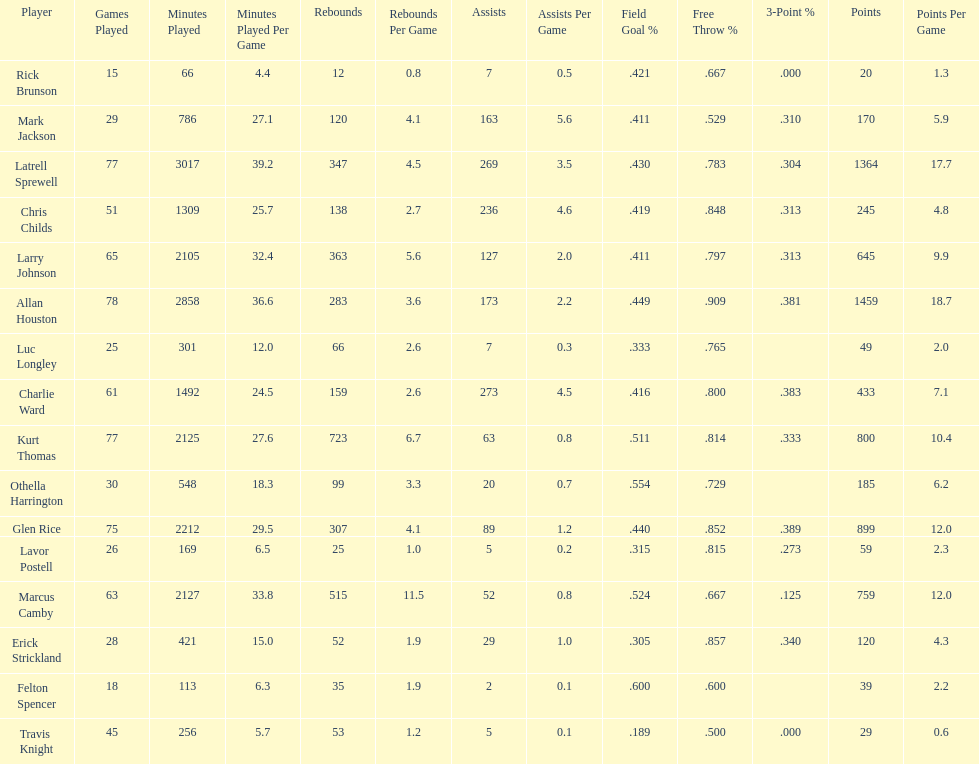Did kurt thomas play more or less than 2126 minutes? Less. 